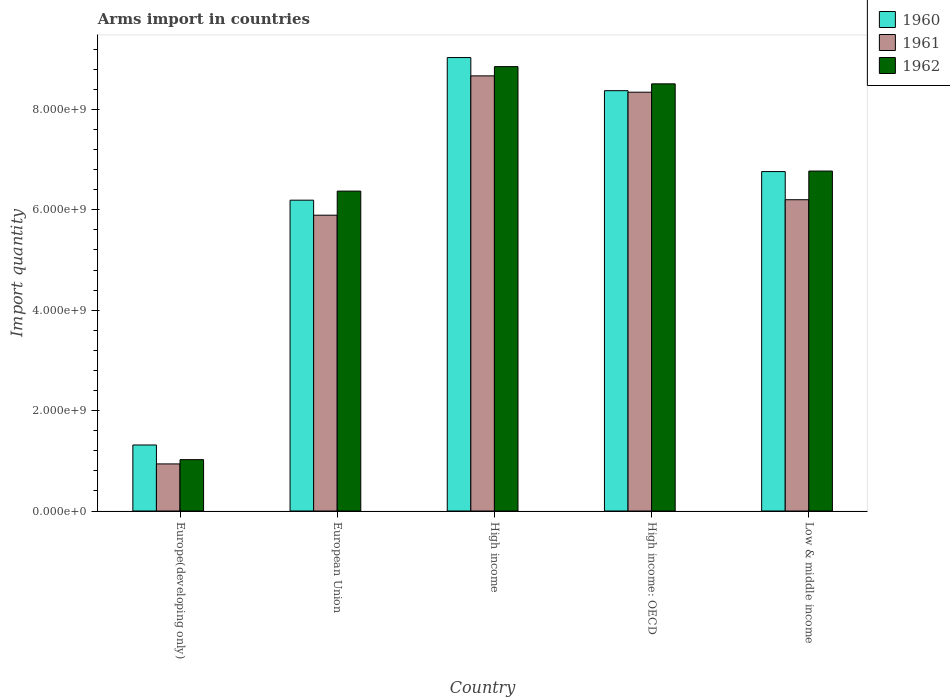In how many cases, is the number of bars for a given country not equal to the number of legend labels?
Keep it short and to the point. 0. What is the total arms import in 1962 in Europe(developing only)?
Keep it short and to the point. 1.02e+09. Across all countries, what is the maximum total arms import in 1961?
Keep it short and to the point. 8.67e+09. Across all countries, what is the minimum total arms import in 1960?
Provide a succinct answer. 1.32e+09. In which country was the total arms import in 1961 maximum?
Give a very brief answer. High income. In which country was the total arms import in 1960 minimum?
Your answer should be very brief. Europe(developing only). What is the total total arms import in 1960 in the graph?
Make the answer very short. 3.17e+1. What is the difference between the total arms import in 1960 in European Union and that in High income?
Keep it short and to the point. -2.84e+09. What is the difference between the total arms import in 1961 in Low & middle income and the total arms import in 1962 in European Union?
Offer a terse response. -1.72e+08. What is the average total arms import in 1960 per country?
Make the answer very short. 6.33e+09. What is the difference between the total arms import of/in 1962 and total arms import of/in 1961 in European Union?
Provide a succinct answer. 4.80e+08. What is the ratio of the total arms import in 1961 in High income: OECD to that in Low & middle income?
Give a very brief answer. 1.35. Is the total arms import in 1962 in Europe(developing only) less than that in High income: OECD?
Your response must be concise. Yes. Is the difference between the total arms import in 1962 in High income and High income: OECD greater than the difference between the total arms import in 1961 in High income and High income: OECD?
Ensure brevity in your answer.  Yes. What is the difference between the highest and the second highest total arms import in 1960?
Your answer should be very brief. 6.60e+08. What is the difference between the highest and the lowest total arms import in 1960?
Ensure brevity in your answer.  7.72e+09. What does the 2nd bar from the left in Low & middle income represents?
Keep it short and to the point. 1961. What does the 1st bar from the right in Low & middle income represents?
Your response must be concise. 1962. Is it the case that in every country, the sum of the total arms import in 1961 and total arms import in 1960 is greater than the total arms import in 1962?
Offer a terse response. Yes. How many bars are there?
Offer a terse response. 15. Are all the bars in the graph horizontal?
Offer a very short reply. No. What is the difference between two consecutive major ticks on the Y-axis?
Your answer should be very brief. 2.00e+09. Does the graph contain any zero values?
Keep it short and to the point. No. Does the graph contain grids?
Your response must be concise. No. Where does the legend appear in the graph?
Provide a succinct answer. Top right. How many legend labels are there?
Make the answer very short. 3. What is the title of the graph?
Provide a short and direct response. Arms import in countries. What is the label or title of the Y-axis?
Your answer should be compact. Import quantity. What is the Import quantity of 1960 in Europe(developing only)?
Offer a very short reply. 1.32e+09. What is the Import quantity of 1961 in Europe(developing only)?
Offer a very short reply. 9.38e+08. What is the Import quantity of 1962 in Europe(developing only)?
Your answer should be compact. 1.02e+09. What is the Import quantity in 1960 in European Union?
Offer a terse response. 6.19e+09. What is the Import quantity of 1961 in European Union?
Provide a succinct answer. 5.89e+09. What is the Import quantity of 1962 in European Union?
Offer a very short reply. 6.37e+09. What is the Import quantity of 1960 in High income?
Give a very brief answer. 9.03e+09. What is the Import quantity in 1961 in High income?
Keep it short and to the point. 8.67e+09. What is the Import quantity in 1962 in High income?
Make the answer very short. 8.85e+09. What is the Import quantity in 1960 in High income: OECD?
Keep it short and to the point. 8.37e+09. What is the Import quantity in 1961 in High income: OECD?
Keep it short and to the point. 8.34e+09. What is the Import quantity of 1962 in High income: OECD?
Offer a terse response. 8.51e+09. What is the Import quantity of 1960 in Low & middle income?
Ensure brevity in your answer.  6.76e+09. What is the Import quantity in 1961 in Low & middle income?
Your response must be concise. 6.20e+09. What is the Import quantity in 1962 in Low & middle income?
Ensure brevity in your answer.  6.77e+09. Across all countries, what is the maximum Import quantity of 1960?
Make the answer very short. 9.03e+09. Across all countries, what is the maximum Import quantity in 1961?
Your answer should be compact. 8.67e+09. Across all countries, what is the maximum Import quantity of 1962?
Your response must be concise. 8.85e+09. Across all countries, what is the minimum Import quantity of 1960?
Provide a short and direct response. 1.32e+09. Across all countries, what is the minimum Import quantity in 1961?
Keep it short and to the point. 9.38e+08. Across all countries, what is the minimum Import quantity of 1962?
Ensure brevity in your answer.  1.02e+09. What is the total Import quantity of 1960 in the graph?
Provide a succinct answer. 3.17e+1. What is the total Import quantity in 1961 in the graph?
Provide a succinct answer. 3.00e+1. What is the total Import quantity in 1962 in the graph?
Keep it short and to the point. 3.15e+1. What is the difference between the Import quantity in 1960 in Europe(developing only) and that in European Union?
Offer a terse response. -4.88e+09. What is the difference between the Import quantity of 1961 in Europe(developing only) and that in European Union?
Ensure brevity in your answer.  -4.95e+09. What is the difference between the Import quantity in 1962 in Europe(developing only) and that in European Union?
Ensure brevity in your answer.  -5.35e+09. What is the difference between the Import quantity in 1960 in Europe(developing only) and that in High income?
Give a very brief answer. -7.72e+09. What is the difference between the Import quantity in 1961 in Europe(developing only) and that in High income?
Your response must be concise. -7.73e+09. What is the difference between the Import quantity of 1962 in Europe(developing only) and that in High income?
Your answer should be very brief. -7.83e+09. What is the difference between the Import quantity of 1960 in Europe(developing only) and that in High income: OECD?
Your answer should be compact. -7.06e+09. What is the difference between the Import quantity in 1961 in Europe(developing only) and that in High income: OECD?
Your answer should be very brief. -7.40e+09. What is the difference between the Import quantity of 1962 in Europe(developing only) and that in High income: OECD?
Your response must be concise. -7.48e+09. What is the difference between the Import quantity in 1960 in Europe(developing only) and that in Low & middle income?
Provide a short and direct response. -5.45e+09. What is the difference between the Import quantity of 1961 in Europe(developing only) and that in Low & middle income?
Your answer should be very brief. -5.26e+09. What is the difference between the Import quantity in 1962 in Europe(developing only) and that in Low & middle income?
Give a very brief answer. -5.75e+09. What is the difference between the Import quantity in 1960 in European Union and that in High income?
Offer a terse response. -2.84e+09. What is the difference between the Import quantity of 1961 in European Union and that in High income?
Your answer should be very brief. -2.78e+09. What is the difference between the Import quantity of 1962 in European Union and that in High income?
Offer a very short reply. -2.48e+09. What is the difference between the Import quantity of 1960 in European Union and that in High income: OECD?
Offer a terse response. -2.18e+09. What is the difference between the Import quantity of 1961 in European Union and that in High income: OECD?
Your answer should be very brief. -2.45e+09. What is the difference between the Import quantity of 1962 in European Union and that in High income: OECD?
Offer a very short reply. -2.14e+09. What is the difference between the Import quantity in 1960 in European Union and that in Low & middle income?
Keep it short and to the point. -5.70e+08. What is the difference between the Import quantity of 1961 in European Union and that in Low & middle income?
Give a very brief answer. -3.08e+08. What is the difference between the Import quantity in 1962 in European Union and that in Low & middle income?
Provide a short and direct response. -3.99e+08. What is the difference between the Import quantity in 1960 in High income and that in High income: OECD?
Make the answer very short. 6.60e+08. What is the difference between the Import quantity of 1961 in High income and that in High income: OECD?
Give a very brief answer. 3.25e+08. What is the difference between the Import quantity in 1962 in High income and that in High income: OECD?
Your answer should be compact. 3.43e+08. What is the difference between the Import quantity of 1960 in High income and that in Low & middle income?
Offer a terse response. 2.27e+09. What is the difference between the Import quantity of 1961 in High income and that in Low & middle income?
Provide a succinct answer. 2.47e+09. What is the difference between the Import quantity of 1962 in High income and that in Low & middle income?
Your answer should be very brief. 2.08e+09. What is the difference between the Import quantity in 1960 in High income: OECD and that in Low & middle income?
Your answer should be compact. 1.61e+09. What is the difference between the Import quantity of 1961 in High income: OECD and that in Low & middle income?
Provide a succinct answer. 2.14e+09. What is the difference between the Import quantity in 1962 in High income: OECD and that in Low & middle income?
Offer a very short reply. 1.74e+09. What is the difference between the Import quantity of 1960 in Europe(developing only) and the Import quantity of 1961 in European Union?
Provide a succinct answer. -4.58e+09. What is the difference between the Import quantity of 1960 in Europe(developing only) and the Import quantity of 1962 in European Union?
Offer a terse response. -5.06e+09. What is the difference between the Import quantity in 1961 in Europe(developing only) and the Import quantity in 1962 in European Union?
Your answer should be very brief. -5.43e+09. What is the difference between the Import quantity of 1960 in Europe(developing only) and the Import quantity of 1961 in High income?
Ensure brevity in your answer.  -7.35e+09. What is the difference between the Import quantity of 1960 in Europe(developing only) and the Import quantity of 1962 in High income?
Give a very brief answer. -7.54e+09. What is the difference between the Import quantity in 1961 in Europe(developing only) and the Import quantity in 1962 in High income?
Ensure brevity in your answer.  -7.91e+09. What is the difference between the Import quantity in 1960 in Europe(developing only) and the Import quantity in 1961 in High income: OECD?
Offer a very short reply. -7.03e+09. What is the difference between the Import quantity in 1960 in Europe(developing only) and the Import quantity in 1962 in High income: OECD?
Offer a very short reply. -7.19e+09. What is the difference between the Import quantity of 1961 in Europe(developing only) and the Import quantity of 1962 in High income: OECD?
Your answer should be very brief. -7.57e+09. What is the difference between the Import quantity in 1960 in Europe(developing only) and the Import quantity in 1961 in Low & middle income?
Your answer should be compact. -4.88e+09. What is the difference between the Import quantity of 1960 in Europe(developing only) and the Import quantity of 1962 in Low & middle income?
Make the answer very short. -5.46e+09. What is the difference between the Import quantity of 1961 in Europe(developing only) and the Import quantity of 1962 in Low & middle income?
Keep it short and to the point. -5.83e+09. What is the difference between the Import quantity in 1960 in European Union and the Import quantity in 1961 in High income?
Provide a short and direct response. -2.48e+09. What is the difference between the Import quantity in 1960 in European Union and the Import quantity in 1962 in High income?
Your answer should be compact. -2.66e+09. What is the difference between the Import quantity of 1961 in European Union and the Import quantity of 1962 in High income?
Keep it short and to the point. -2.96e+09. What is the difference between the Import quantity of 1960 in European Union and the Import quantity of 1961 in High income: OECD?
Your answer should be very brief. -2.15e+09. What is the difference between the Import quantity of 1960 in European Union and the Import quantity of 1962 in High income: OECD?
Offer a terse response. -2.32e+09. What is the difference between the Import quantity of 1961 in European Union and the Import quantity of 1962 in High income: OECD?
Offer a terse response. -2.62e+09. What is the difference between the Import quantity in 1960 in European Union and the Import quantity in 1961 in Low & middle income?
Make the answer very short. -9.00e+06. What is the difference between the Import quantity in 1960 in European Union and the Import quantity in 1962 in Low & middle income?
Offer a terse response. -5.80e+08. What is the difference between the Import quantity in 1961 in European Union and the Import quantity in 1962 in Low & middle income?
Offer a terse response. -8.79e+08. What is the difference between the Import quantity of 1960 in High income and the Import quantity of 1961 in High income: OECD?
Provide a short and direct response. 6.90e+08. What is the difference between the Import quantity of 1960 in High income and the Import quantity of 1962 in High income: OECD?
Keep it short and to the point. 5.24e+08. What is the difference between the Import quantity in 1961 in High income and the Import quantity in 1962 in High income: OECD?
Offer a terse response. 1.59e+08. What is the difference between the Import quantity of 1960 in High income and the Import quantity of 1961 in Low & middle income?
Your answer should be very brief. 2.83e+09. What is the difference between the Import quantity of 1960 in High income and the Import quantity of 1962 in Low & middle income?
Make the answer very short. 2.26e+09. What is the difference between the Import quantity of 1961 in High income and the Import quantity of 1962 in Low & middle income?
Make the answer very short. 1.90e+09. What is the difference between the Import quantity of 1960 in High income: OECD and the Import quantity of 1961 in Low & middle income?
Give a very brief answer. 2.17e+09. What is the difference between the Import quantity of 1960 in High income: OECD and the Import quantity of 1962 in Low & middle income?
Provide a short and direct response. 1.60e+09. What is the difference between the Import quantity in 1961 in High income: OECD and the Import quantity in 1962 in Low & middle income?
Provide a succinct answer. 1.57e+09. What is the average Import quantity of 1960 per country?
Provide a succinct answer. 6.33e+09. What is the average Import quantity in 1961 per country?
Offer a very short reply. 6.01e+09. What is the average Import quantity in 1962 per country?
Ensure brevity in your answer.  6.30e+09. What is the difference between the Import quantity in 1960 and Import quantity in 1961 in Europe(developing only)?
Your answer should be very brief. 3.77e+08. What is the difference between the Import quantity in 1960 and Import quantity in 1962 in Europe(developing only)?
Make the answer very short. 2.92e+08. What is the difference between the Import quantity in 1961 and Import quantity in 1962 in Europe(developing only)?
Your answer should be very brief. -8.50e+07. What is the difference between the Import quantity of 1960 and Import quantity of 1961 in European Union?
Make the answer very short. 2.99e+08. What is the difference between the Import quantity in 1960 and Import quantity in 1962 in European Union?
Make the answer very short. -1.81e+08. What is the difference between the Import quantity in 1961 and Import quantity in 1962 in European Union?
Ensure brevity in your answer.  -4.80e+08. What is the difference between the Import quantity of 1960 and Import quantity of 1961 in High income?
Offer a terse response. 3.65e+08. What is the difference between the Import quantity of 1960 and Import quantity of 1962 in High income?
Your response must be concise. 1.81e+08. What is the difference between the Import quantity in 1961 and Import quantity in 1962 in High income?
Offer a terse response. -1.84e+08. What is the difference between the Import quantity of 1960 and Import quantity of 1961 in High income: OECD?
Your answer should be compact. 3.00e+07. What is the difference between the Import quantity of 1960 and Import quantity of 1962 in High income: OECD?
Provide a short and direct response. -1.36e+08. What is the difference between the Import quantity in 1961 and Import quantity in 1962 in High income: OECD?
Keep it short and to the point. -1.66e+08. What is the difference between the Import quantity in 1960 and Import quantity in 1961 in Low & middle income?
Your answer should be compact. 5.61e+08. What is the difference between the Import quantity in 1960 and Import quantity in 1962 in Low & middle income?
Make the answer very short. -1.00e+07. What is the difference between the Import quantity of 1961 and Import quantity of 1962 in Low & middle income?
Keep it short and to the point. -5.71e+08. What is the ratio of the Import quantity in 1960 in Europe(developing only) to that in European Union?
Provide a succinct answer. 0.21. What is the ratio of the Import quantity of 1961 in Europe(developing only) to that in European Union?
Your answer should be very brief. 0.16. What is the ratio of the Import quantity of 1962 in Europe(developing only) to that in European Union?
Your response must be concise. 0.16. What is the ratio of the Import quantity in 1960 in Europe(developing only) to that in High income?
Provide a succinct answer. 0.15. What is the ratio of the Import quantity in 1961 in Europe(developing only) to that in High income?
Ensure brevity in your answer.  0.11. What is the ratio of the Import quantity in 1962 in Europe(developing only) to that in High income?
Make the answer very short. 0.12. What is the ratio of the Import quantity of 1960 in Europe(developing only) to that in High income: OECD?
Ensure brevity in your answer.  0.16. What is the ratio of the Import quantity of 1961 in Europe(developing only) to that in High income: OECD?
Offer a very short reply. 0.11. What is the ratio of the Import quantity of 1962 in Europe(developing only) to that in High income: OECD?
Offer a very short reply. 0.12. What is the ratio of the Import quantity in 1960 in Europe(developing only) to that in Low & middle income?
Provide a short and direct response. 0.19. What is the ratio of the Import quantity in 1961 in Europe(developing only) to that in Low & middle income?
Your response must be concise. 0.15. What is the ratio of the Import quantity in 1962 in Europe(developing only) to that in Low & middle income?
Keep it short and to the point. 0.15. What is the ratio of the Import quantity in 1960 in European Union to that in High income?
Offer a terse response. 0.69. What is the ratio of the Import quantity of 1961 in European Union to that in High income?
Keep it short and to the point. 0.68. What is the ratio of the Import quantity in 1962 in European Union to that in High income?
Keep it short and to the point. 0.72. What is the ratio of the Import quantity in 1960 in European Union to that in High income: OECD?
Provide a succinct answer. 0.74. What is the ratio of the Import quantity in 1961 in European Union to that in High income: OECD?
Provide a succinct answer. 0.71. What is the ratio of the Import quantity of 1962 in European Union to that in High income: OECD?
Keep it short and to the point. 0.75. What is the ratio of the Import quantity in 1960 in European Union to that in Low & middle income?
Your answer should be very brief. 0.92. What is the ratio of the Import quantity in 1961 in European Union to that in Low & middle income?
Ensure brevity in your answer.  0.95. What is the ratio of the Import quantity of 1962 in European Union to that in Low & middle income?
Give a very brief answer. 0.94. What is the ratio of the Import quantity of 1960 in High income to that in High income: OECD?
Make the answer very short. 1.08. What is the ratio of the Import quantity of 1961 in High income to that in High income: OECD?
Keep it short and to the point. 1.04. What is the ratio of the Import quantity in 1962 in High income to that in High income: OECD?
Your answer should be very brief. 1.04. What is the ratio of the Import quantity in 1960 in High income to that in Low & middle income?
Offer a very short reply. 1.34. What is the ratio of the Import quantity of 1961 in High income to that in Low & middle income?
Make the answer very short. 1.4. What is the ratio of the Import quantity of 1962 in High income to that in Low & middle income?
Give a very brief answer. 1.31. What is the ratio of the Import quantity in 1960 in High income: OECD to that in Low & middle income?
Your response must be concise. 1.24. What is the ratio of the Import quantity of 1961 in High income: OECD to that in Low & middle income?
Make the answer very short. 1.35. What is the ratio of the Import quantity in 1962 in High income: OECD to that in Low & middle income?
Ensure brevity in your answer.  1.26. What is the difference between the highest and the second highest Import quantity of 1960?
Offer a very short reply. 6.60e+08. What is the difference between the highest and the second highest Import quantity in 1961?
Offer a very short reply. 3.25e+08. What is the difference between the highest and the second highest Import quantity of 1962?
Provide a succinct answer. 3.43e+08. What is the difference between the highest and the lowest Import quantity in 1960?
Your answer should be very brief. 7.72e+09. What is the difference between the highest and the lowest Import quantity in 1961?
Your response must be concise. 7.73e+09. What is the difference between the highest and the lowest Import quantity in 1962?
Provide a succinct answer. 7.83e+09. 